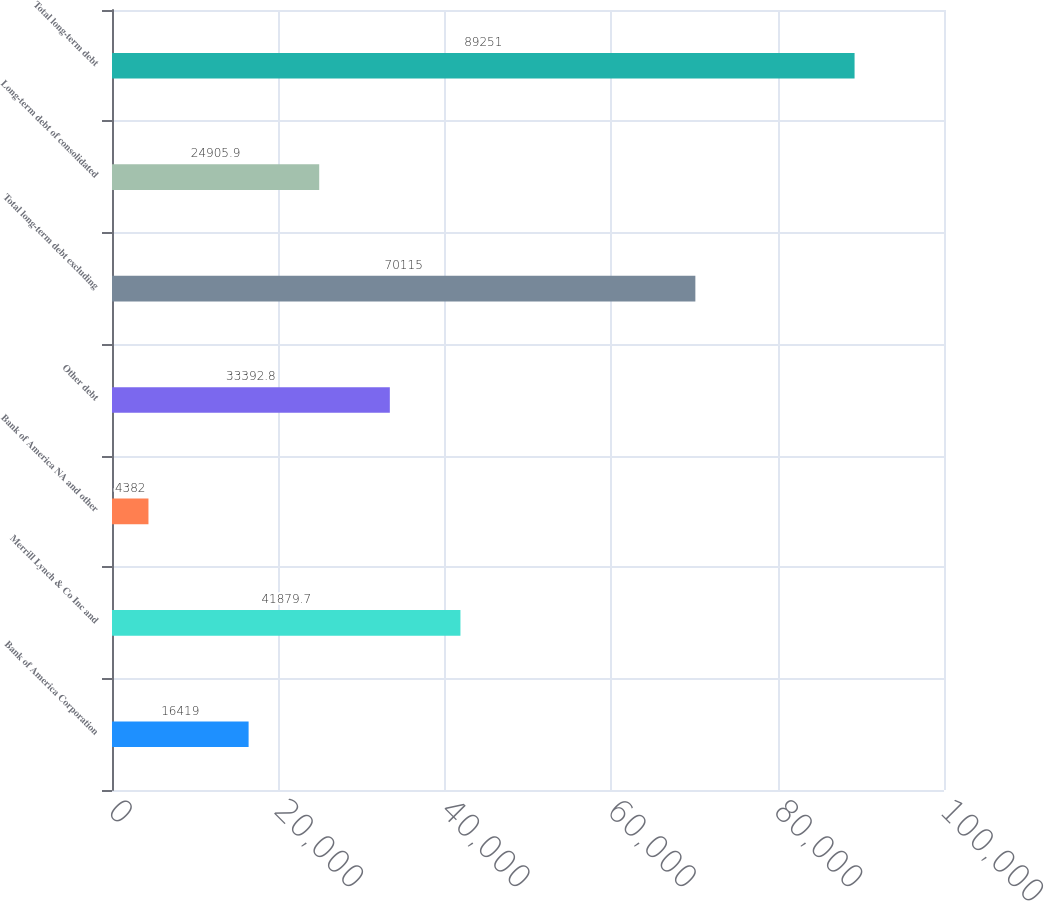<chart> <loc_0><loc_0><loc_500><loc_500><bar_chart><fcel>Bank of America Corporation<fcel>Merrill Lynch & Co Inc and<fcel>Bank of America NA and other<fcel>Other debt<fcel>Total long-term debt excluding<fcel>Long-term debt of consolidated<fcel>Total long-term debt<nl><fcel>16419<fcel>41879.7<fcel>4382<fcel>33392.8<fcel>70115<fcel>24905.9<fcel>89251<nl></chart> 